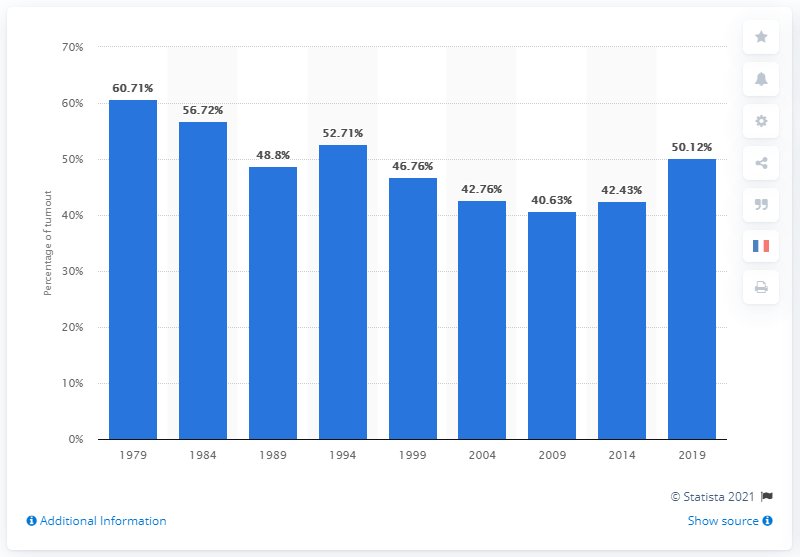Give some essential details in this illustration. In 2019, the electoral participation in France was 50.12%. 